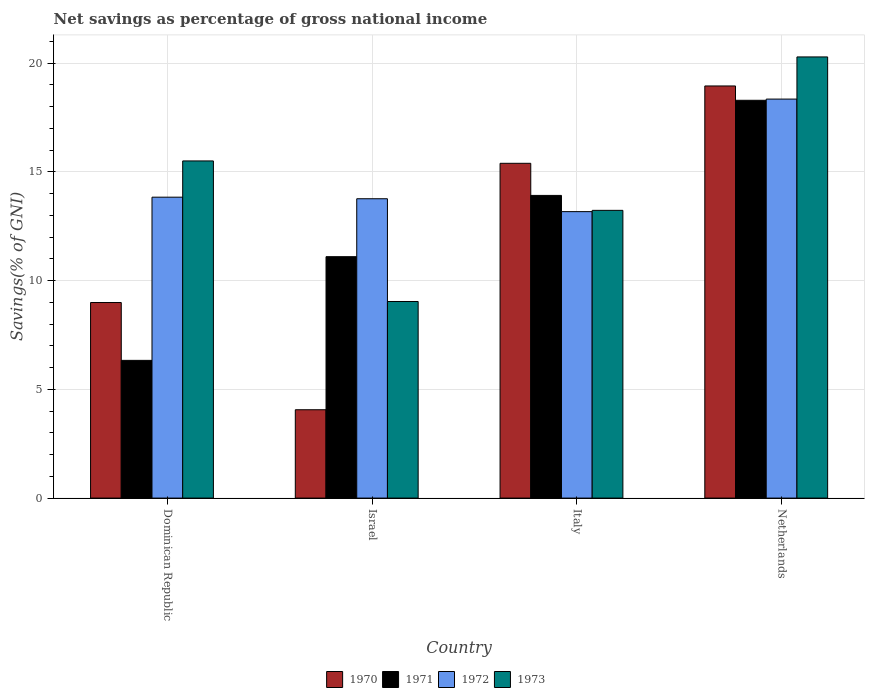How many bars are there on the 1st tick from the left?
Your answer should be very brief. 4. What is the label of the 3rd group of bars from the left?
Your response must be concise. Italy. In how many cases, is the number of bars for a given country not equal to the number of legend labels?
Provide a succinct answer. 0. What is the total savings in 1971 in Netherlands?
Your answer should be compact. 18.29. Across all countries, what is the maximum total savings in 1970?
Your response must be concise. 18.95. Across all countries, what is the minimum total savings in 1973?
Your answer should be very brief. 9.04. What is the total total savings in 1973 in the graph?
Offer a terse response. 58.07. What is the difference between the total savings in 1970 in Dominican Republic and that in Netherlands?
Your answer should be very brief. -9.96. What is the difference between the total savings in 1971 in Netherlands and the total savings in 1970 in Italy?
Provide a succinct answer. 2.9. What is the average total savings in 1971 per country?
Provide a succinct answer. 12.41. What is the difference between the total savings of/in 1970 and total savings of/in 1973 in Italy?
Provide a succinct answer. 2.16. What is the ratio of the total savings in 1972 in Dominican Republic to that in Italy?
Your answer should be compact. 1.05. Is the total savings in 1971 in Israel less than that in Italy?
Make the answer very short. Yes. Is the difference between the total savings in 1970 in Dominican Republic and Netherlands greater than the difference between the total savings in 1973 in Dominican Republic and Netherlands?
Offer a very short reply. No. What is the difference between the highest and the second highest total savings in 1970?
Offer a terse response. -9.96. What is the difference between the highest and the lowest total savings in 1973?
Provide a short and direct response. 11.25. In how many countries, is the total savings in 1970 greater than the average total savings in 1970 taken over all countries?
Provide a short and direct response. 2. Is the sum of the total savings in 1972 in Dominican Republic and Israel greater than the maximum total savings in 1973 across all countries?
Your answer should be compact. Yes. Is it the case that in every country, the sum of the total savings in 1972 and total savings in 1973 is greater than the sum of total savings in 1971 and total savings in 1970?
Keep it short and to the point. No. Is it the case that in every country, the sum of the total savings in 1972 and total savings in 1970 is greater than the total savings in 1971?
Make the answer very short. Yes. Are all the bars in the graph horizontal?
Ensure brevity in your answer.  No. Does the graph contain any zero values?
Your answer should be very brief. No. Where does the legend appear in the graph?
Ensure brevity in your answer.  Bottom center. How many legend labels are there?
Your answer should be compact. 4. How are the legend labels stacked?
Provide a short and direct response. Horizontal. What is the title of the graph?
Make the answer very short. Net savings as percentage of gross national income. What is the label or title of the Y-axis?
Provide a short and direct response. Savings(% of GNI). What is the Savings(% of GNI) of 1970 in Dominican Republic?
Your answer should be compact. 8.99. What is the Savings(% of GNI) of 1971 in Dominican Republic?
Offer a terse response. 6.33. What is the Savings(% of GNI) of 1972 in Dominican Republic?
Offer a very short reply. 13.84. What is the Savings(% of GNI) in 1973 in Dominican Republic?
Your response must be concise. 15.5. What is the Savings(% of GNI) of 1970 in Israel?
Keep it short and to the point. 4.06. What is the Savings(% of GNI) of 1971 in Israel?
Ensure brevity in your answer.  11.1. What is the Savings(% of GNI) in 1972 in Israel?
Your response must be concise. 13.77. What is the Savings(% of GNI) of 1973 in Israel?
Your answer should be very brief. 9.04. What is the Savings(% of GNI) in 1970 in Italy?
Provide a short and direct response. 15.4. What is the Savings(% of GNI) of 1971 in Italy?
Make the answer very short. 13.92. What is the Savings(% of GNI) of 1972 in Italy?
Give a very brief answer. 13.17. What is the Savings(% of GNI) in 1973 in Italy?
Offer a terse response. 13.23. What is the Savings(% of GNI) in 1970 in Netherlands?
Your response must be concise. 18.95. What is the Savings(% of GNI) of 1971 in Netherlands?
Your answer should be very brief. 18.29. What is the Savings(% of GNI) in 1972 in Netherlands?
Give a very brief answer. 18.35. What is the Savings(% of GNI) in 1973 in Netherlands?
Give a very brief answer. 20.29. Across all countries, what is the maximum Savings(% of GNI) in 1970?
Ensure brevity in your answer.  18.95. Across all countries, what is the maximum Savings(% of GNI) in 1971?
Offer a terse response. 18.29. Across all countries, what is the maximum Savings(% of GNI) of 1972?
Your answer should be compact. 18.35. Across all countries, what is the maximum Savings(% of GNI) in 1973?
Offer a very short reply. 20.29. Across all countries, what is the minimum Savings(% of GNI) of 1970?
Offer a terse response. 4.06. Across all countries, what is the minimum Savings(% of GNI) in 1971?
Make the answer very short. 6.33. Across all countries, what is the minimum Savings(% of GNI) of 1972?
Your answer should be compact. 13.17. Across all countries, what is the minimum Savings(% of GNI) in 1973?
Give a very brief answer. 9.04. What is the total Savings(% of GNI) of 1970 in the graph?
Keep it short and to the point. 47.41. What is the total Savings(% of GNI) of 1971 in the graph?
Offer a terse response. 49.65. What is the total Savings(% of GNI) in 1972 in the graph?
Offer a terse response. 59.13. What is the total Savings(% of GNI) of 1973 in the graph?
Ensure brevity in your answer.  58.07. What is the difference between the Savings(% of GNI) of 1970 in Dominican Republic and that in Israel?
Provide a succinct answer. 4.93. What is the difference between the Savings(% of GNI) of 1971 in Dominican Republic and that in Israel?
Ensure brevity in your answer.  -4.77. What is the difference between the Savings(% of GNI) of 1972 in Dominican Republic and that in Israel?
Your answer should be compact. 0.07. What is the difference between the Savings(% of GNI) in 1973 in Dominican Republic and that in Israel?
Your response must be concise. 6.46. What is the difference between the Savings(% of GNI) in 1970 in Dominican Republic and that in Italy?
Provide a short and direct response. -6.4. What is the difference between the Savings(% of GNI) in 1971 in Dominican Republic and that in Italy?
Offer a very short reply. -7.59. What is the difference between the Savings(% of GNI) in 1972 in Dominican Republic and that in Italy?
Your response must be concise. 0.66. What is the difference between the Savings(% of GNI) of 1973 in Dominican Republic and that in Italy?
Make the answer very short. 2.27. What is the difference between the Savings(% of GNI) in 1970 in Dominican Republic and that in Netherlands?
Ensure brevity in your answer.  -9.96. What is the difference between the Savings(% of GNI) in 1971 in Dominican Republic and that in Netherlands?
Keep it short and to the point. -11.96. What is the difference between the Savings(% of GNI) of 1972 in Dominican Republic and that in Netherlands?
Your response must be concise. -4.51. What is the difference between the Savings(% of GNI) in 1973 in Dominican Republic and that in Netherlands?
Offer a terse response. -4.78. What is the difference between the Savings(% of GNI) of 1970 in Israel and that in Italy?
Ensure brevity in your answer.  -11.33. What is the difference between the Savings(% of GNI) of 1971 in Israel and that in Italy?
Provide a short and direct response. -2.82. What is the difference between the Savings(% of GNI) in 1972 in Israel and that in Italy?
Provide a succinct answer. 0.59. What is the difference between the Savings(% of GNI) of 1973 in Israel and that in Italy?
Provide a succinct answer. -4.19. What is the difference between the Savings(% of GNI) of 1970 in Israel and that in Netherlands?
Provide a short and direct response. -14.89. What is the difference between the Savings(% of GNI) in 1971 in Israel and that in Netherlands?
Your answer should be very brief. -7.19. What is the difference between the Savings(% of GNI) of 1972 in Israel and that in Netherlands?
Your response must be concise. -4.58. What is the difference between the Savings(% of GNI) of 1973 in Israel and that in Netherlands?
Give a very brief answer. -11.25. What is the difference between the Savings(% of GNI) of 1970 in Italy and that in Netherlands?
Your answer should be very brief. -3.56. What is the difference between the Savings(% of GNI) of 1971 in Italy and that in Netherlands?
Make the answer very short. -4.37. What is the difference between the Savings(% of GNI) of 1972 in Italy and that in Netherlands?
Offer a very short reply. -5.18. What is the difference between the Savings(% of GNI) of 1973 in Italy and that in Netherlands?
Offer a terse response. -7.06. What is the difference between the Savings(% of GNI) of 1970 in Dominican Republic and the Savings(% of GNI) of 1971 in Israel?
Provide a succinct answer. -2.11. What is the difference between the Savings(% of GNI) of 1970 in Dominican Republic and the Savings(% of GNI) of 1972 in Israel?
Your answer should be very brief. -4.77. What is the difference between the Savings(% of GNI) of 1970 in Dominican Republic and the Savings(% of GNI) of 1973 in Israel?
Provide a succinct answer. -0.05. What is the difference between the Savings(% of GNI) in 1971 in Dominican Republic and the Savings(% of GNI) in 1972 in Israel?
Give a very brief answer. -7.43. What is the difference between the Savings(% of GNI) of 1971 in Dominican Republic and the Savings(% of GNI) of 1973 in Israel?
Make the answer very short. -2.71. What is the difference between the Savings(% of GNI) of 1972 in Dominican Republic and the Savings(% of GNI) of 1973 in Israel?
Provide a short and direct response. 4.8. What is the difference between the Savings(% of GNI) of 1970 in Dominican Republic and the Savings(% of GNI) of 1971 in Italy?
Your answer should be compact. -4.93. What is the difference between the Savings(% of GNI) of 1970 in Dominican Republic and the Savings(% of GNI) of 1972 in Italy?
Give a very brief answer. -4.18. What is the difference between the Savings(% of GNI) of 1970 in Dominican Republic and the Savings(% of GNI) of 1973 in Italy?
Make the answer very short. -4.24. What is the difference between the Savings(% of GNI) of 1971 in Dominican Republic and the Savings(% of GNI) of 1972 in Italy?
Your answer should be compact. -6.84. What is the difference between the Savings(% of GNI) in 1971 in Dominican Republic and the Savings(% of GNI) in 1973 in Italy?
Provide a succinct answer. -6.9. What is the difference between the Savings(% of GNI) of 1972 in Dominican Republic and the Savings(% of GNI) of 1973 in Italy?
Offer a terse response. 0.61. What is the difference between the Savings(% of GNI) of 1970 in Dominican Republic and the Savings(% of GNI) of 1971 in Netherlands?
Offer a very short reply. -9.3. What is the difference between the Savings(% of GNI) of 1970 in Dominican Republic and the Savings(% of GNI) of 1972 in Netherlands?
Give a very brief answer. -9.36. What is the difference between the Savings(% of GNI) in 1970 in Dominican Republic and the Savings(% of GNI) in 1973 in Netherlands?
Give a very brief answer. -11.29. What is the difference between the Savings(% of GNI) in 1971 in Dominican Republic and the Savings(% of GNI) in 1972 in Netherlands?
Provide a short and direct response. -12.02. What is the difference between the Savings(% of GNI) of 1971 in Dominican Republic and the Savings(% of GNI) of 1973 in Netherlands?
Your answer should be compact. -13.95. What is the difference between the Savings(% of GNI) in 1972 in Dominican Republic and the Savings(% of GNI) in 1973 in Netherlands?
Your response must be concise. -6.45. What is the difference between the Savings(% of GNI) in 1970 in Israel and the Savings(% of GNI) in 1971 in Italy?
Offer a terse response. -9.86. What is the difference between the Savings(% of GNI) in 1970 in Israel and the Savings(% of GNI) in 1972 in Italy?
Your answer should be compact. -9.11. What is the difference between the Savings(% of GNI) in 1970 in Israel and the Savings(% of GNI) in 1973 in Italy?
Provide a succinct answer. -9.17. What is the difference between the Savings(% of GNI) of 1971 in Israel and the Savings(% of GNI) of 1972 in Italy?
Your response must be concise. -2.07. What is the difference between the Savings(% of GNI) in 1971 in Israel and the Savings(% of GNI) in 1973 in Italy?
Your answer should be very brief. -2.13. What is the difference between the Savings(% of GNI) in 1972 in Israel and the Savings(% of GNI) in 1973 in Italy?
Your response must be concise. 0.53. What is the difference between the Savings(% of GNI) in 1970 in Israel and the Savings(% of GNI) in 1971 in Netherlands?
Offer a very short reply. -14.23. What is the difference between the Savings(% of GNI) of 1970 in Israel and the Savings(% of GNI) of 1972 in Netherlands?
Keep it short and to the point. -14.29. What is the difference between the Savings(% of GNI) in 1970 in Israel and the Savings(% of GNI) in 1973 in Netherlands?
Your response must be concise. -16.22. What is the difference between the Savings(% of GNI) in 1971 in Israel and the Savings(% of GNI) in 1972 in Netherlands?
Give a very brief answer. -7.25. What is the difference between the Savings(% of GNI) in 1971 in Israel and the Savings(% of GNI) in 1973 in Netherlands?
Give a very brief answer. -9.19. What is the difference between the Savings(% of GNI) in 1972 in Israel and the Savings(% of GNI) in 1973 in Netherlands?
Keep it short and to the point. -6.52. What is the difference between the Savings(% of GNI) in 1970 in Italy and the Savings(% of GNI) in 1971 in Netherlands?
Your response must be concise. -2.9. What is the difference between the Savings(% of GNI) in 1970 in Italy and the Savings(% of GNI) in 1972 in Netherlands?
Your answer should be very brief. -2.95. What is the difference between the Savings(% of GNI) in 1970 in Italy and the Savings(% of GNI) in 1973 in Netherlands?
Give a very brief answer. -4.89. What is the difference between the Savings(% of GNI) in 1971 in Italy and the Savings(% of GNI) in 1972 in Netherlands?
Make the answer very short. -4.43. What is the difference between the Savings(% of GNI) in 1971 in Italy and the Savings(% of GNI) in 1973 in Netherlands?
Your answer should be very brief. -6.37. What is the difference between the Savings(% of GNI) of 1972 in Italy and the Savings(% of GNI) of 1973 in Netherlands?
Your response must be concise. -7.11. What is the average Savings(% of GNI) in 1970 per country?
Offer a terse response. 11.85. What is the average Savings(% of GNI) in 1971 per country?
Your answer should be very brief. 12.41. What is the average Savings(% of GNI) in 1972 per country?
Keep it short and to the point. 14.78. What is the average Savings(% of GNI) of 1973 per country?
Your answer should be very brief. 14.52. What is the difference between the Savings(% of GNI) in 1970 and Savings(% of GNI) in 1971 in Dominican Republic?
Make the answer very short. 2.66. What is the difference between the Savings(% of GNI) in 1970 and Savings(% of GNI) in 1972 in Dominican Republic?
Your answer should be compact. -4.84. What is the difference between the Savings(% of GNI) of 1970 and Savings(% of GNI) of 1973 in Dominican Republic?
Provide a short and direct response. -6.51. What is the difference between the Savings(% of GNI) in 1971 and Savings(% of GNI) in 1972 in Dominican Republic?
Keep it short and to the point. -7.5. What is the difference between the Savings(% of GNI) in 1971 and Savings(% of GNI) in 1973 in Dominican Republic?
Offer a terse response. -9.17. What is the difference between the Savings(% of GNI) of 1972 and Savings(% of GNI) of 1973 in Dominican Republic?
Ensure brevity in your answer.  -1.67. What is the difference between the Savings(% of GNI) in 1970 and Savings(% of GNI) in 1971 in Israel?
Provide a succinct answer. -7.04. What is the difference between the Savings(% of GNI) of 1970 and Savings(% of GNI) of 1972 in Israel?
Provide a succinct answer. -9.7. What is the difference between the Savings(% of GNI) in 1970 and Savings(% of GNI) in 1973 in Israel?
Provide a succinct answer. -4.98. What is the difference between the Savings(% of GNI) of 1971 and Savings(% of GNI) of 1972 in Israel?
Your answer should be compact. -2.66. What is the difference between the Savings(% of GNI) in 1971 and Savings(% of GNI) in 1973 in Israel?
Keep it short and to the point. 2.06. What is the difference between the Savings(% of GNI) in 1972 and Savings(% of GNI) in 1973 in Israel?
Your answer should be compact. 4.73. What is the difference between the Savings(% of GNI) of 1970 and Savings(% of GNI) of 1971 in Italy?
Provide a succinct answer. 1.48. What is the difference between the Savings(% of GNI) in 1970 and Savings(% of GNI) in 1972 in Italy?
Give a very brief answer. 2.22. What is the difference between the Savings(% of GNI) of 1970 and Savings(% of GNI) of 1973 in Italy?
Keep it short and to the point. 2.16. What is the difference between the Savings(% of GNI) in 1971 and Savings(% of GNI) in 1972 in Italy?
Offer a terse response. 0.75. What is the difference between the Savings(% of GNI) in 1971 and Savings(% of GNI) in 1973 in Italy?
Ensure brevity in your answer.  0.69. What is the difference between the Savings(% of GNI) in 1972 and Savings(% of GNI) in 1973 in Italy?
Your response must be concise. -0.06. What is the difference between the Savings(% of GNI) in 1970 and Savings(% of GNI) in 1971 in Netherlands?
Make the answer very short. 0.66. What is the difference between the Savings(% of GNI) in 1970 and Savings(% of GNI) in 1972 in Netherlands?
Offer a terse response. 0.6. What is the difference between the Savings(% of GNI) in 1970 and Savings(% of GNI) in 1973 in Netherlands?
Provide a short and direct response. -1.33. What is the difference between the Savings(% of GNI) of 1971 and Savings(% of GNI) of 1972 in Netherlands?
Give a very brief answer. -0.06. What is the difference between the Savings(% of GNI) in 1971 and Savings(% of GNI) in 1973 in Netherlands?
Your answer should be very brief. -1.99. What is the difference between the Savings(% of GNI) of 1972 and Savings(% of GNI) of 1973 in Netherlands?
Offer a very short reply. -1.94. What is the ratio of the Savings(% of GNI) in 1970 in Dominican Republic to that in Israel?
Give a very brief answer. 2.21. What is the ratio of the Savings(% of GNI) of 1971 in Dominican Republic to that in Israel?
Offer a very short reply. 0.57. What is the ratio of the Savings(% of GNI) of 1972 in Dominican Republic to that in Israel?
Make the answer very short. 1.01. What is the ratio of the Savings(% of GNI) in 1973 in Dominican Republic to that in Israel?
Give a very brief answer. 1.71. What is the ratio of the Savings(% of GNI) in 1970 in Dominican Republic to that in Italy?
Your answer should be compact. 0.58. What is the ratio of the Savings(% of GNI) of 1971 in Dominican Republic to that in Italy?
Give a very brief answer. 0.46. What is the ratio of the Savings(% of GNI) in 1972 in Dominican Republic to that in Italy?
Keep it short and to the point. 1.05. What is the ratio of the Savings(% of GNI) in 1973 in Dominican Republic to that in Italy?
Give a very brief answer. 1.17. What is the ratio of the Savings(% of GNI) in 1970 in Dominican Republic to that in Netherlands?
Keep it short and to the point. 0.47. What is the ratio of the Savings(% of GNI) in 1971 in Dominican Republic to that in Netherlands?
Give a very brief answer. 0.35. What is the ratio of the Savings(% of GNI) of 1972 in Dominican Republic to that in Netherlands?
Make the answer very short. 0.75. What is the ratio of the Savings(% of GNI) of 1973 in Dominican Republic to that in Netherlands?
Ensure brevity in your answer.  0.76. What is the ratio of the Savings(% of GNI) of 1970 in Israel to that in Italy?
Your answer should be very brief. 0.26. What is the ratio of the Savings(% of GNI) in 1971 in Israel to that in Italy?
Offer a very short reply. 0.8. What is the ratio of the Savings(% of GNI) of 1972 in Israel to that in Italy?
Give a very brief answer. 1.04. What is the ratio of the Savings(% of GNI) in 1973 in Israel to that in Italy?
Ensure brevity in your answer.  0.68. What is the ratio of the Savings(% of GNI) in 1970 in Israel to that in Netherlands?
Your answer should be very brief. 0.21. What is the ratio of the Savings(% of GNI) of 1971 in Israel to that in Netherlands?
Your response must be concise. 0.61. What is the ratio of the Savings(% of GNI) in 1972 in Israel to that in Netherlands?
Your answer should be very brief. 0.75. What is the ratio of the Savings(% of GNI) in 1973 in Israel to that in Netherlands?
Your response must be concise. 0.45. What is the ratio of the Savings(% of GNI) of 1970 in Italy to that in Netherlands?
Your response must be concise. 0.81. What is the ratio of the Savings(% of GNI) in 1971 in Italy to that in Netherlands?
Your response must be concise. 0.76. What is the ratio of the Savings(% of GNI) of 1972 in Italy to that in Netherlands?
Provide a short and direct response. 0.72. What is the ratio of the Savings(% of GNI) in 1973 in Italy to that in Netherlands?
Keep it short and to the point. 0.65. What is the difference between the highest and the second highest Savings(% of GNI) in 1970?
Your answer should be compact. 3.56. What is the difference between the highest and the second highest Savings(% of GNI) in 1971?
Your answer should be compact. 4.37. What is the difference between the highest and the second highest Savings(% of GNI) of 1972?
Make the answer very short. 4.51. What is the difference between the highest and the second highest Savings(% of GNI) of 1973?
Your response must be concise. 4.78. What is the difference between the highest and the lowest Savings(% of GNI) in 1970?
Ensure brevity in your answer.  14.89. What is the difference between the highest and the lowest Savings(% of GNI) of 1971?
Offer a terse response. 11.96. What is the difference between the highest and the lowest Savings(% of GNI) in 1972?
Provide a succinct answer. 5.18. What is the difference between the highest and the lowest Savings(% of GNI) in 1973?
Provide a short and direct response. 11.25. 